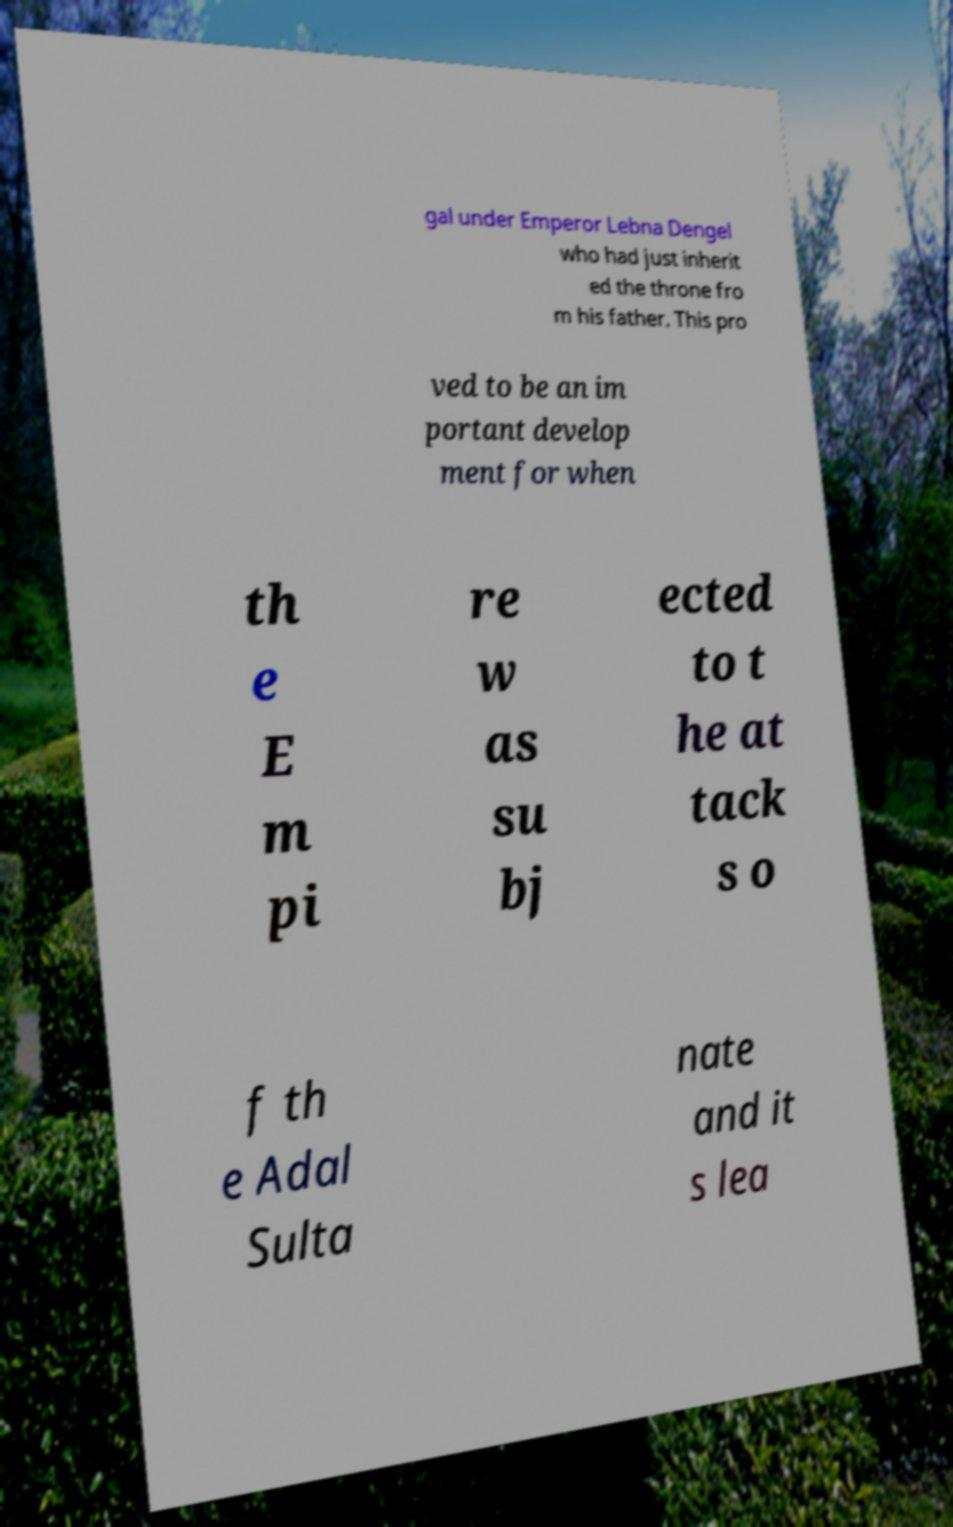Can you accurately transcribe the text from the provided image for me? gal under Emperor Lebna Dengel who had just inherit ed the throne fro m his father. This pro ved to be an im portant develop ment for when th e E m pi re w as su bj ected to t he at tack s o f th e Adal Sulta nate and it s lea 